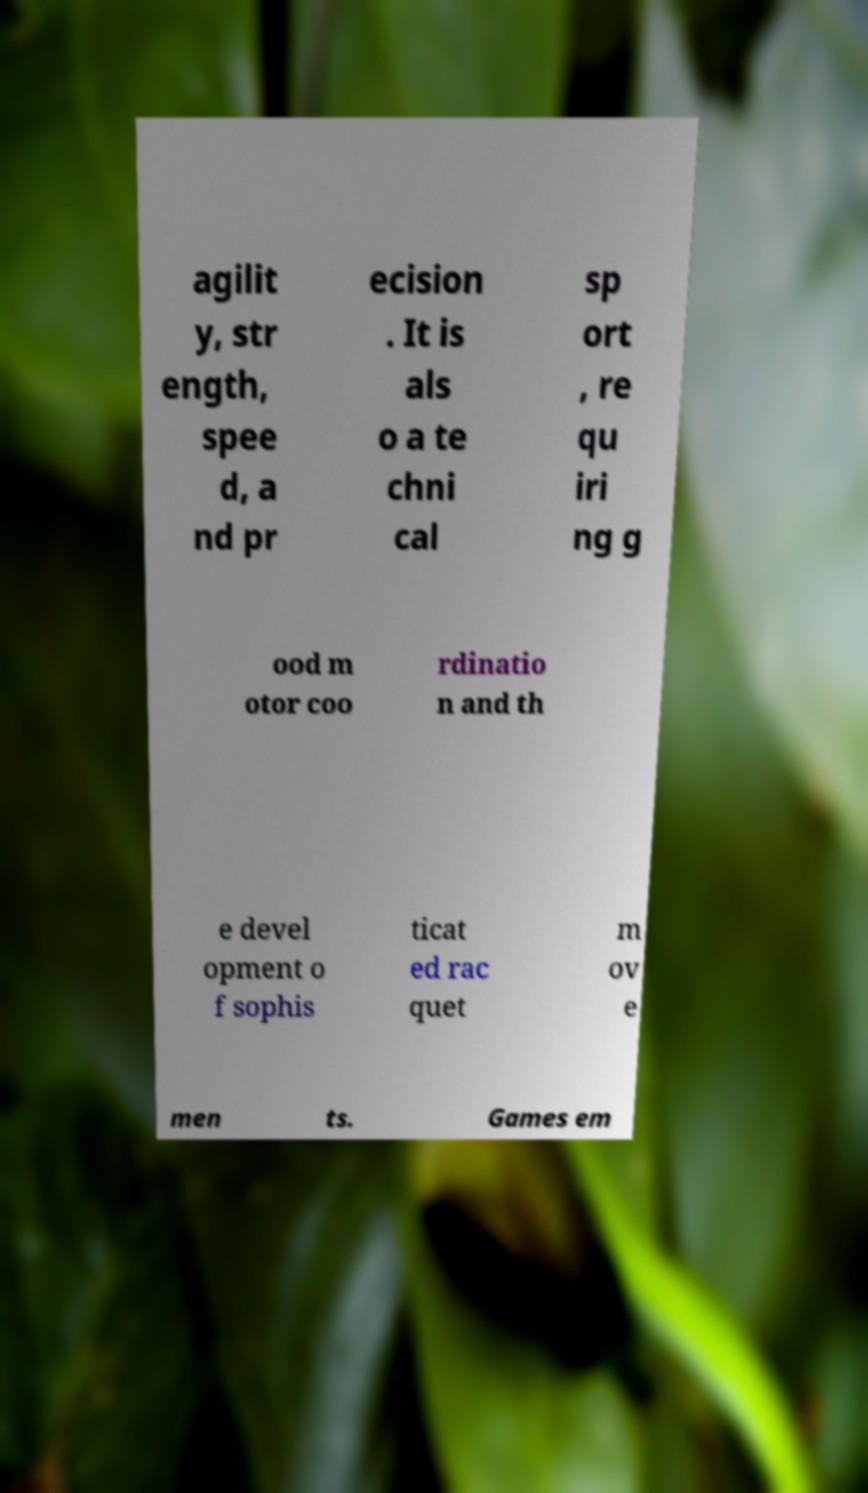There's text embedded in this image that I need extracted. Can you transcribe it verbatim? agilit y, str ength, spee d, a nd pr ecision . It is als o a te chni cal sp ort , re qu iri ng g ood m otor coo rdinatio n and th e devel opment o f sophis ticat ed rac quet m ov e men ts. Games em 